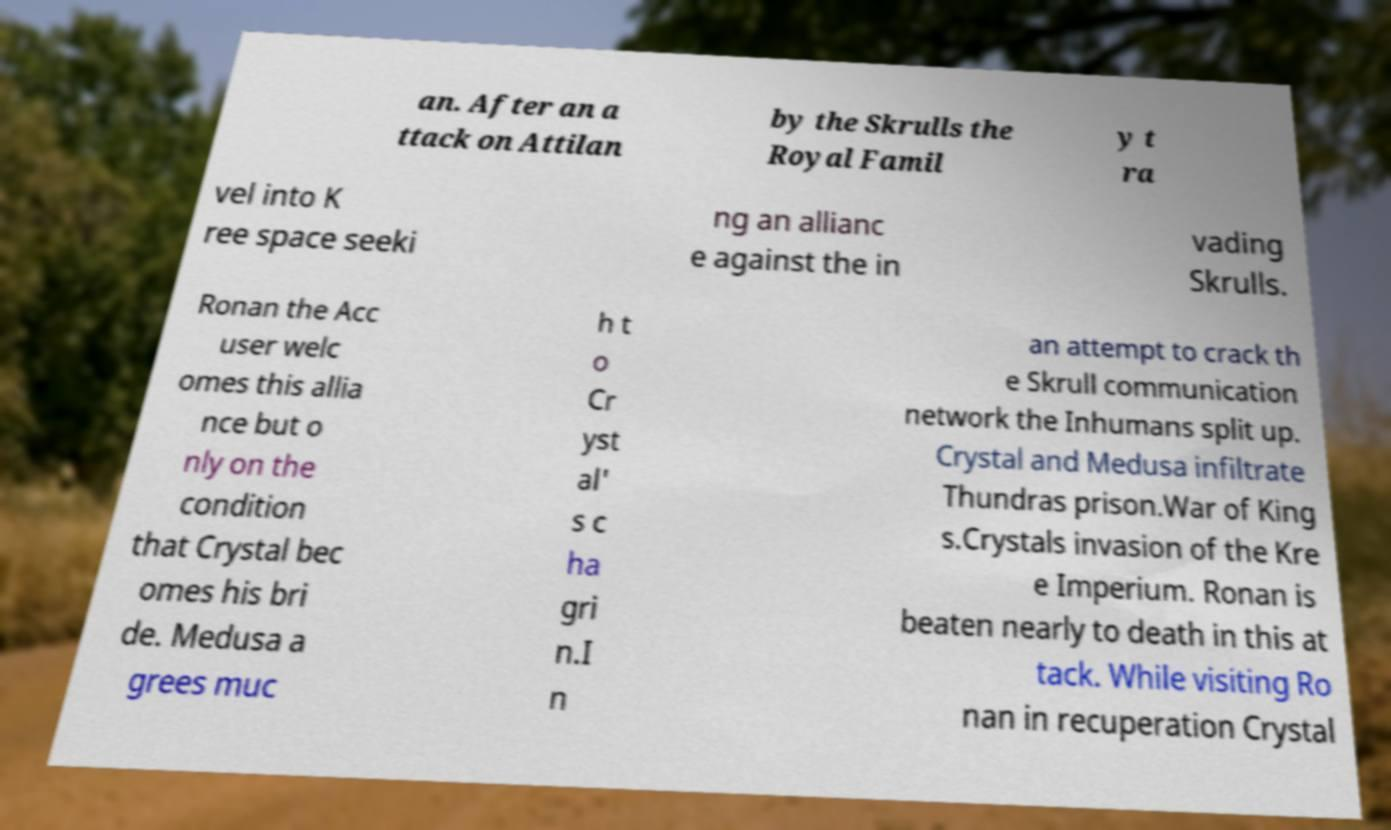Please read and relay the text visible in this image. What does it say? an. After an a ttack on Attilan by the Skrulls the Royal Famil y t ra vel into K ree space seeki ng an allianc e against the in vading Skrulls. Ronan the Acc user welc omes this allia nce but o nly on the condition that Crystal bec omes his bri de. Medusa a grees muc h t o Cr yst al' s c ha gri n.I n an attempt to crack th e Skrull communication network the Inhumans split up. Crystal and Medusa infiltrate Thundras prison.War of King s.Crystals invasion of the Kre e Imperium. Ronan is beaten nearly to death in this at tack. While visiting Ro nan in recuperation Crystal 